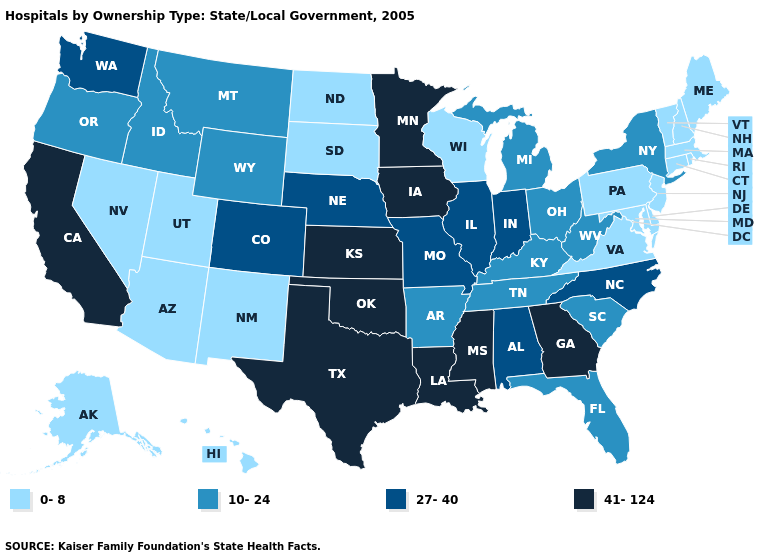How many symbols are there in the legend?
Concise answer only. 4. Which states have the highest value in the USA?
Keep it brief. California, Georgia, Iowa, Kansas, Louisiana, Minnesota, Mississippi, Oklahoma, Texas. What is the value of Missouri?
Write a very short answer. 27-40. What is the lowest value in states that border North Carolina?
Keep it brief. 0-8. Name the states that have a value in the range 41-124?
Short answer required. California, Georgia, Iowa, Kansas, Louisiana, Minnesota, Mississippi, Oklahoma, Texas. Name the states that have a value in the range 41-124?
Short answer required. California, Georgia, Iowa, Kansas, Louisiana, Minnesota, Mississippi, Oklahoma, Texas. Name the states that have a value in the range 41-124?
Concise answer only. California, Georgia, Iowa, Kansas, Louisiana, Minnesota, Mississippi, Oklahoma, Texas. What is the lowest value in the West?
Give a very brief answer. 0-8. Is the legend a continuous bar?
Short answer required. No. What is the highest value in states that border South Carolina?
Quick response, please. 41-124. Name the states that have a value in the range 10-24?
Keep it brief. Arkansas, Florida, Idaho, Kentucky, Michigan, Montana, New York, Ohio, Oregon, South Carolina, Tennessee, West Virginia, Wyoming. What is the lowest value in the USA?
Keep it brief. 0-8. What is the lowest value in the USA?
Give a very brief answer. 0-8. What is the value of Missouri?
Keep it brief. 27-40. Name the states that have a value in the range 0-8?
Give a very brief answer. Alaska, Arizona, Connecticut, Delaware, Hawaii, Maine, Maryland, Massachusetts, Nevada, New Hampshire, New Jersey, New Mexico, North Dakota, Pennsylvania, Rhode Island, South Dakota, Utah, Vermont, Virginia, Wisconsin. 